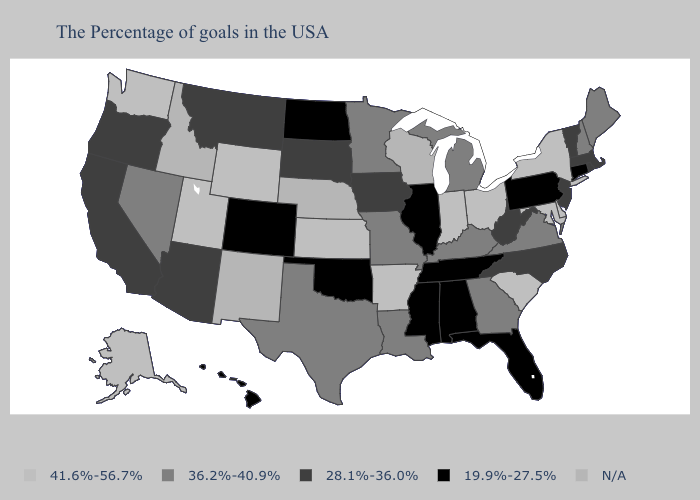Which states hav the highest value in the Northeast?
Be succinct. New York. Name the states that have a value in the range 36.2%-40.9%?
Short answer required. Maine, New Hampshire, Virginia, Georgia, Michigan, Kentucky, Louisiana, Missouri, Minnesota, Texas, Nevada. Does the map have missing data?
Quick response, please. Yes. Is the legend a continuous bar?
Give a very brief answer. No. Which states have the highest value in the USA?
Be succinct. New York, Delaware, Maryland, South Carolina, Ohio, Indiana, Arkansas, Kansas, Wyoming, Utah, Washington, Alaska. Name the states that have a value in the range N/A?
Quick response, please. Wisconsin, Nebraska, New Mexico, Idaho. Does New Jersey have the lowest value in the USA?
Short answer required. No. Does the map have missing data?
Give a very brief answer. Yes. Does the map have missing data?
Short answer required. Yes. Does Utah have the highest value in the USA?
Give a very brief answer. Yes. Name the states that have a value in the range 36.2%-40.9%?
Write a very short answer. Maine, New Hampshire, Virginia, Georgia, Michigan, Kentucky, Louisiana, Missouri, Minnesota, Texas, Nevada. Name the states that have a value in the range N/A?
Write a very short answer. Wisconsin, Nebraska, New Mexico, Idaho. Name the states that have a value in the range 36.2%-40.9%?
Concise answer only. Maine, New Hampshire, Virginia, Georgia, Michigan, Kentucky, Louisiana, Missouri, Minnesota, Texas, Nevada. Name the states that have a value in the range 19.9%-27.5%?
Be succinct. Connecticut, Pennsylvania, Florida, Alabama, Tennessee, Illinois, Mississippi, Oklahoma, North Dakota, Colorado, Hawaii. 